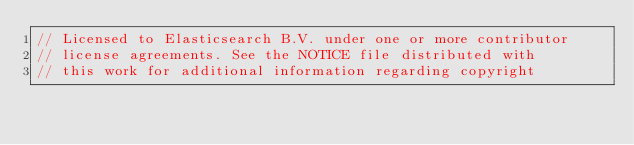<code> <loc_0><loc_0><loc_500><loc_500><_Go_>// Licensed to Elasticsearch B.V. under one or more contributor
// license agreements. See the NOTICE file distributed with
// this work for additional information regarding copyright</code> 